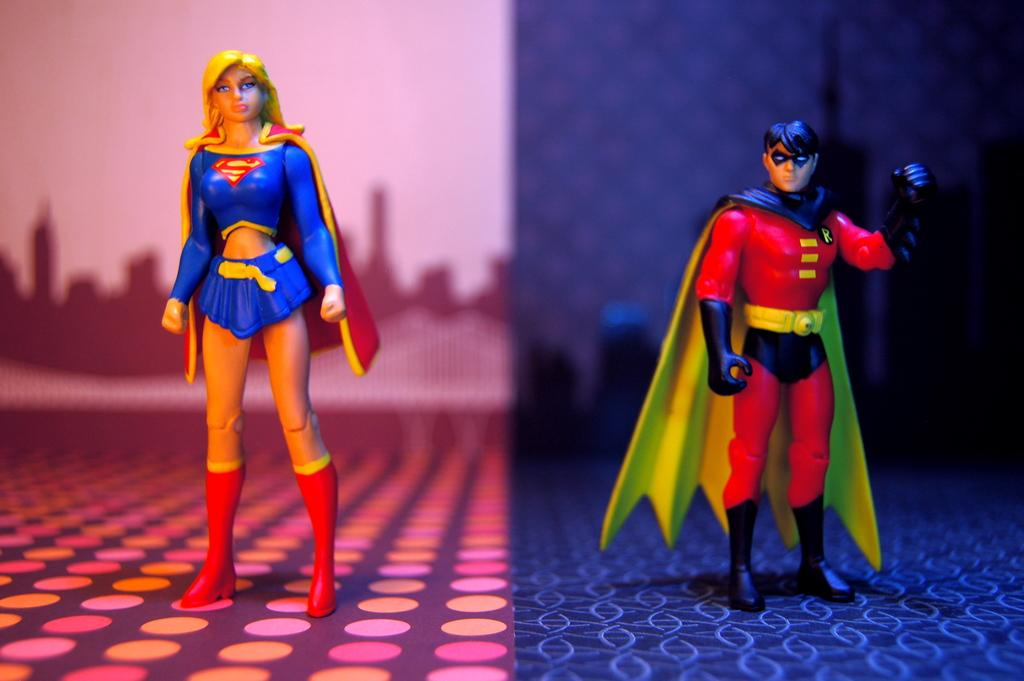What type of toy is on the left side of the image? There is a toy of a superhuman on the left side of the image. What color is the toy? The toy is blue in color. What can be seen on the right side of the image? There is a person standing on the right side of the image. What is the person wearing? The person is wearing a red dress. What type of ship can be seen sailing in the background of the image? There is no ship visible in the image; it only features a toy and a person. How many strings are attached to the toy in the image? There are no strings attached to the toy in the image. 